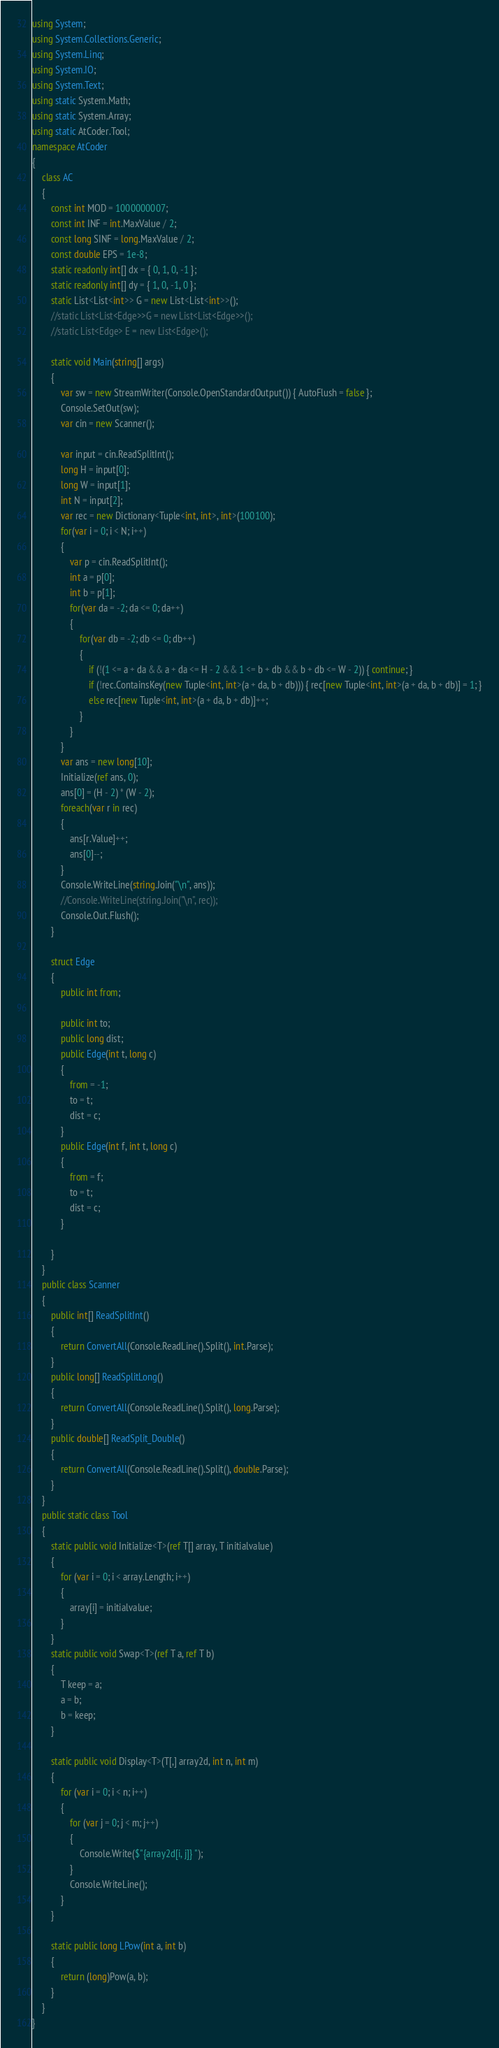<code> <loc_0><loc_0><loc_500><loc_500><_C#_>using System;
using System.Collections.Generic;
using System.Linq;
using System.IO;
using System.Text;
using static System.Math;
using static System.Array;
using static AtCoder.Tool;
namespace AtCoder
{
    class AC
    {
        const int MOD = 1000000007;
        const int INF = int.MaxValue / 2;
        const long SINF = long.MaxValue / 2;
        const double EPS = 1e-8;
        static readonly int[] dx = { 0, 1, 0, -1 };
        static readonly int[] dy = { 1, 0, -1, 0 };
        static List<List<int>> G = new List<List<int>>();
        //static List<List<Edge>>G = new List<List<Edge>>();
        //static List<Edge> E = new List<Edge>();

        static void Main(string[] args)
        {
            var sw = new StreamWriter(Console.OpenStandardOutput()) { AutoFlush = false };
            Console.SetOut(sw);
            var cin = new Scanner();

            var input = cin.ReadSplitInt();
            long H = input[0];
            long W = input[1];
            int N = input[2];
            var rec = new Dictionary<Tuple<int, int>, int>(100100);
            for(var i = 0; i < N; i++)
            {
                var p = cin.ReadSplitInt();
                int a = p[0];
                int b = p[1];
                for(var da = -2; da <= 0; da++)
                {
                    for(var db = -2; db <= 0; db++)
                    {
                        if (!(1 <= a + da && a + da <= H - 2 && 1 <= b + db && b + db <= W - 2)) { continue; }
                        if (!rec.ContainsKey(new Tuple<int, int>(a + da, b + db))) { rec[new Tuple<int, int>(a + da, b + db)] = 1; }
                        else rec[new Tuple<int, int>(a + da, b + db)]++;
                    }
                }
            }
            var ans = new long[10];
            Initialize(ref ans, 0);
            ans[0] = (H - 2) * (W - 2);
            foreach(var r in rec)
            {
                ans[r.Value]++;
                ans[0]--;
            }
            Console.WriteLine(string.Join("\n", ans));
            //Console.WriteLine(string.Join("\n", rec));
            Console.Out.Flush();
        }
        
        struct Edge
        {
            public int from;

            public int to;
            public long dist;
            public Edge(int t, long c)
            {
                from = -1;
                to = t;
                dist = c;
            }
            public Edge(int f, int t, long c)
            {
                from = f;
                to = t;
                dist = c;
            }

        }
    }
    public class Scanner
    {
        public int[] ReadSplitInt()
        {
            return ConvertAll(Console.ReadLine().Split(), int.Parse);
        }
        public long[] ReadSplitLong()
        {
            return ConvertAll(Console.ReadLine().Split(), long.Parse);
        }
        public double[] ReadSplit_Double()
        {
            return ConvertAll(Console.ReadLine().Split(), double.Parse);
        }
    }
    public static class Tool
    {
        static public void Initialize<T>(ref T[] array, T initialvalue)
        {
            for (var i = 0; i < array.Length; i++)
            {
                array[i] = initialvalue;
            }
        }
        static public void Swap<T>(ref T a, ref T b)
        {
            T keep = a;
            a = b;
            b = keep;
        }

        static public void Display<T>(T[,] array2d, int n, int m)
        {
            for (var i = 0; i < n; i++)
            {
                for (var j = 0; j < m; j++)
                {
                    Console.Write($"{array2d[i, j]} ");
                }
                Console.WriteLine();
            }
        }

        static public long LPow(int a, int b)
        {
            return (long)Pow(a, b);
        }
    }
}
</code> 